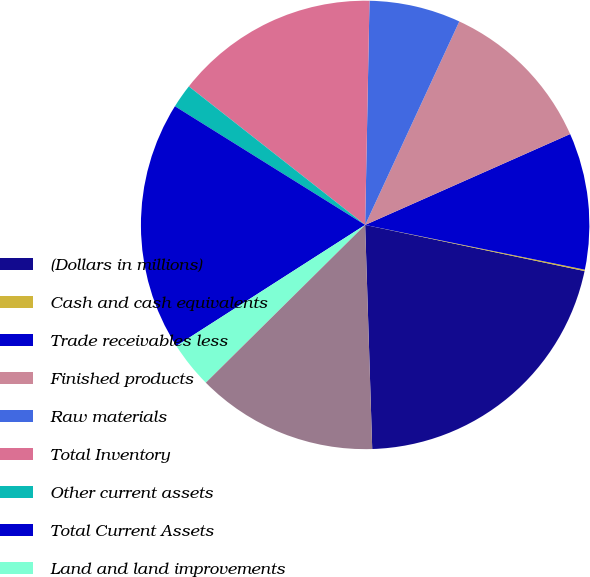<chart> <loc_0><loc_0><loc_500><loc_500><pie_chart><fcel>(Dollars in millions)<fcel>Cash and cash equivalents<fcel>Trade receivables less<fcel>Finished products<fcel>Raw materials<fcel>Total Inventory<fcel>Other current assets<fcel>Total Current Assets<fcel>Land and land improvements<fcel>Buildings and fixtures<nl><fcel>21.2%<fcel>0.1%<fcel>9.84%<fcel>11.46%<fcel>6.59%<fcel>14.71%<fcel>1.72%<fcel>17.95%<fcel>3.35%<fcel>13.08%<nl></chart> 